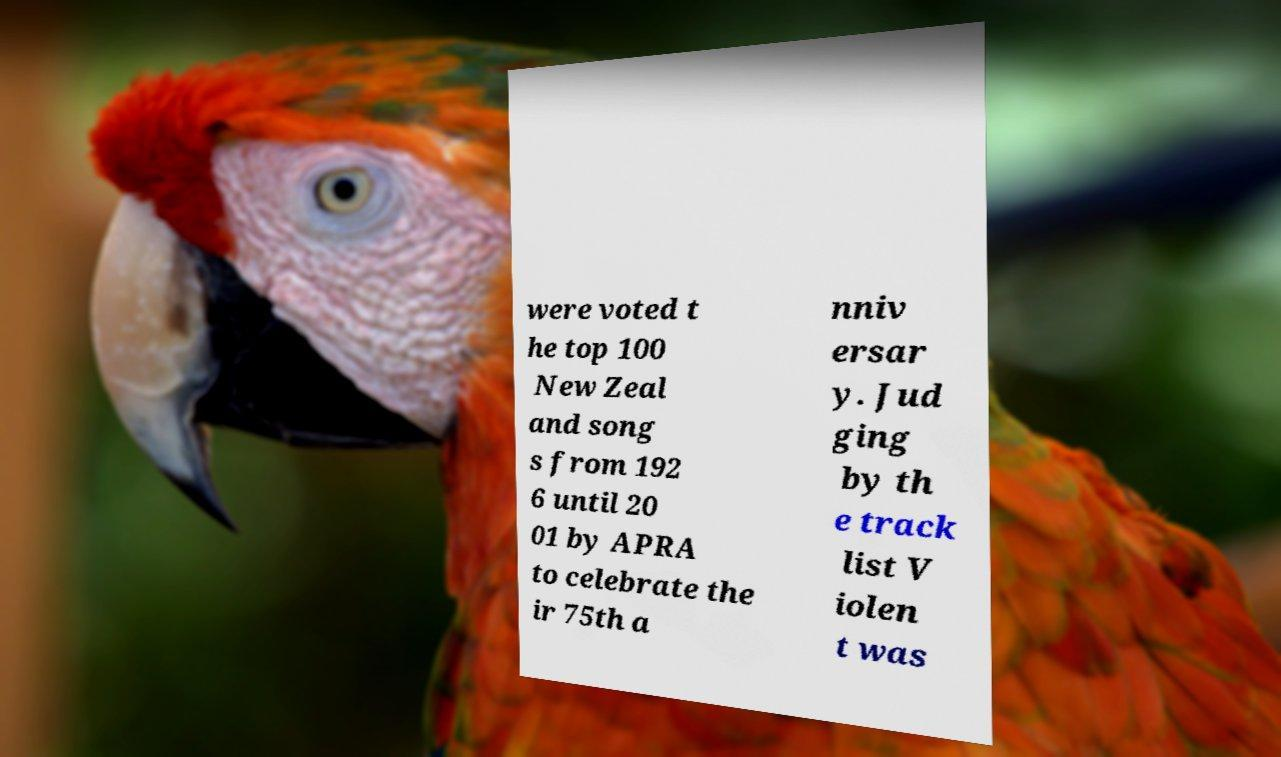Could you extract and type out the text from this image? were voted t he top 100 New Zeal and song s from 192 6 until 20 01 by APRA to celebrate the ir 75th a nniv ersar y. Jud ging by th e track list V iolen t was 